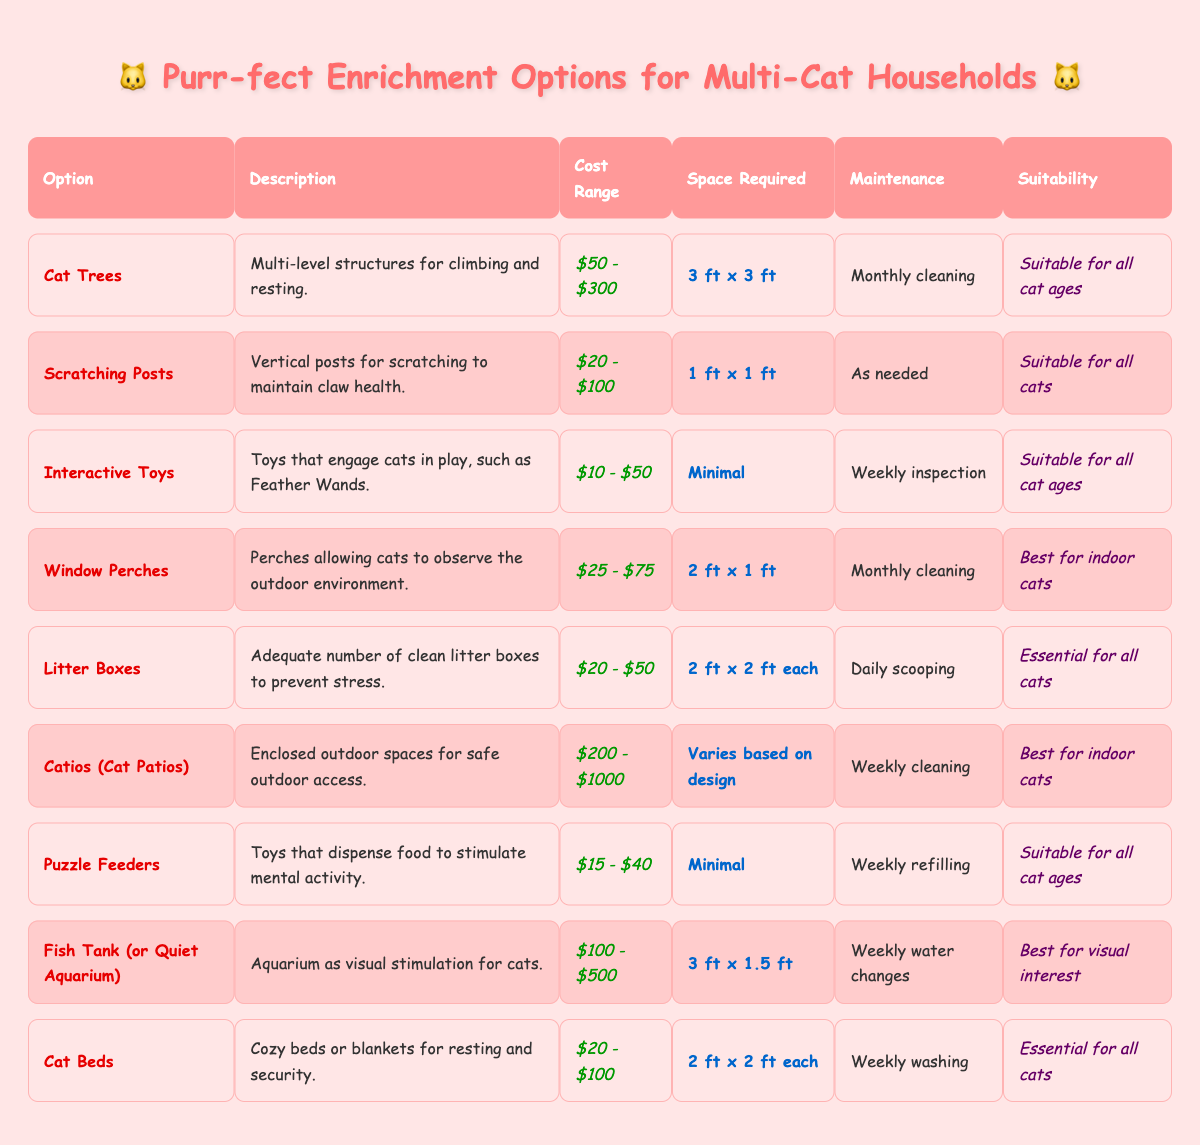What is the cost range for Cat Trees? The table lists the cost range for Cat Trees under the "Cost Range" column, which shows it as "$50 - $300".
Answer: $50 - $300 How much space is required for a scratching post? Under the "Space Required" column for Scratching Posts, it states that the space required is "1 ft x 1 ft".
Answer: 1 ft x 1 ft Are interactive toys suitable for all cat ages? The "Suitability" column for Interactive Toys indicates "Suitable for all cat ages", confirming that they are appropriate for any age of cat.
Answer: Yes What is the maintenance frequency for Cat Beds? Looking at the "Maintenance" column for Cat Beds, it specifies "Weekly washing", which indicates how often maintenance is needed.
Answer: Weekly washing If I were to purchase a fish tank, what is the minimum cost I should expect to pay? The "Cost Range" for Fish Tank or Quiet Aquarium indicates the minimum is $100, which shows the lowest price point for this option.
Answer: $100 Which option requires the most space? By comparing the "Space Required" for each option, "Cat Trees" requires "3 ft x 3 ft", which is larger than the others listed.
Answer: Cat Trees What is the difference in space required between Litter Boxes and Cat Beds? The space for Litter Boxes is "2 ft x 2 ft each" and for Cat Beds is also "2 ft x 2 ft each", therefore the difference is 0 because both require the same space.
Answer: 0 What is the average cost range of all the options listed? First, we note all the cost ranges and convert them to average values: (50+300)/2, (20+100)/2, (10+50)/2, (25+75)/2, (20+50)/2, (200+1000)/2, (15+40)/2, (100+500)/2, (20+100)/2. This gives averages: $175, $60, $30, $50, $35, $600, $27.50, $300, $60. The average of these averages is (175+60+30+50+35+600+27.5+300+60)/9 = 164.39.
Answer: $164.39 Is there any option that is not suitable for all cats? In the table, Catios are listed under "Suitability" as "Best for indoor cats", indicating they are not suitable for all cats.
Answer: Yes How often do puzzle feeders need to be refilled? In the table, the "Maintenance" column for Puzzle Feeders states that they require "Weekly refilling".
Answer: Weekly refilling 